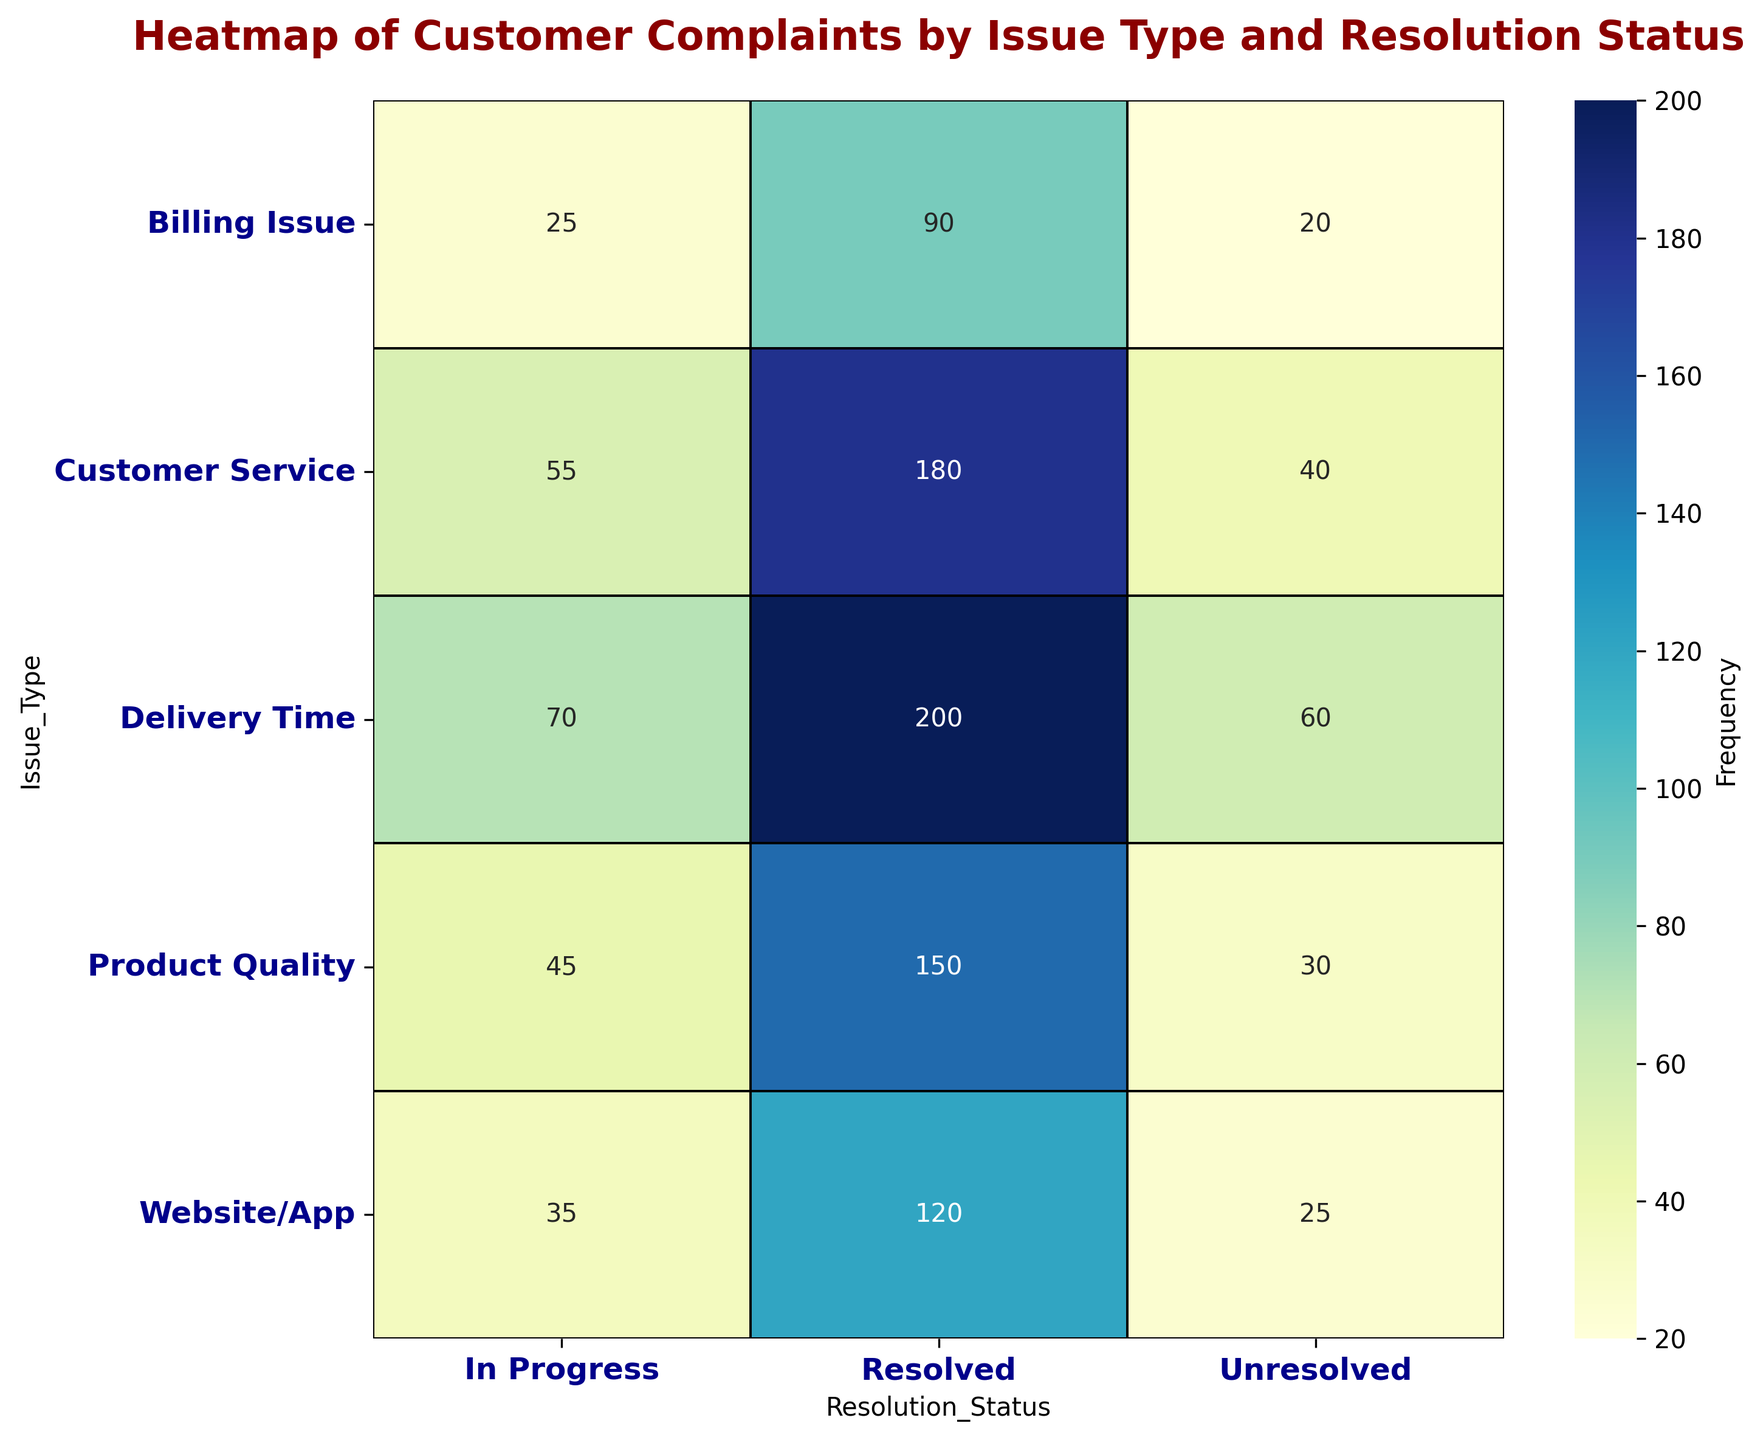What's the most frequent type of issue being resolved? Look at the 'Resolved' column and find the highest number. The value for 'Delivery Time' under the 'Resolved' column is 200, which is the highest.
Answer: Delivery Time How many total complaints are in progress? Sum the 'In Progress' values across all issue types: 45 (Product Quality) + 70 (Delivery Time) + 55 (Customer Service) + 25 (Billing Issue) + 35 (Website/App) = 230.
Answer: 230 Which issue type has the least number of unresolved cases? Look at the 'Unresolved' column and find the lowest number. The 'Billing Issue' has the lowest value with 20.
Answer: Billing Issue What is the difference between resolved and unresolved complaints for Customer Service? Subtract the 'Unresolved' count from the 'Resolved' count for 'Customer Service': 180 (Resolved) - 40 (Unresolved) = 140.
Answer: 140 Is the frequency of unresolved issues for Delivery Time greater than that for Product Quality? Compare the 'Unresolved' values for 'Delivery Time' and 'Product Quality': 60 (Delivery Time) > 30 (Product Quality).
Answer: Yes Which issue type has more in-progress complaints: Product Quality or Website/App? Compare the 'In Progress' values for both issue types: 45 (Product Quality) and 35 (Website/App). 45 is greater.
Answer: Product Quality What fraction of resolved complaints are related to the Website/App? Use the resolved value for Website/App and divide by the total resolved value. 120 (Website/App) / (150 + 200 + 180 + 90 + 120) = 120 / 740 ≈ 0.162.
Answer: Approximately 0.162 Compare the total number of complaints for Delivery Time and Product Quality. Which is higher? Sum the values for each issue type and compare. Delivery Time: 200 (Resolved) + 60 (Unresolved) + 70 (In Progress) = 330, Product Quality: 150 (Resolved) + 30 (Unresolved) + 45 (In Progress) = 225. Delivery Time is higher.
Answer: Delivery Time What percentage of all unresolved complaints are due to Customer Service issues? Find the total unresolved value first, and then the percentage for Customer Service. Total unresolved: 30 + 60 + 40 + 20 + 25 = 175. Customer Service unresolved: 40. (40 / 175) * 100 ≈ 22.86%.
Answer: Approximately 22.86% What visual cue indicates the most resolved complaints? The largest and darkest cell in the 'Resolved' column visually indicates the highest number, which corresponds to 'Delivery Time'.
Answer: Large dark cell under Delivery Time 